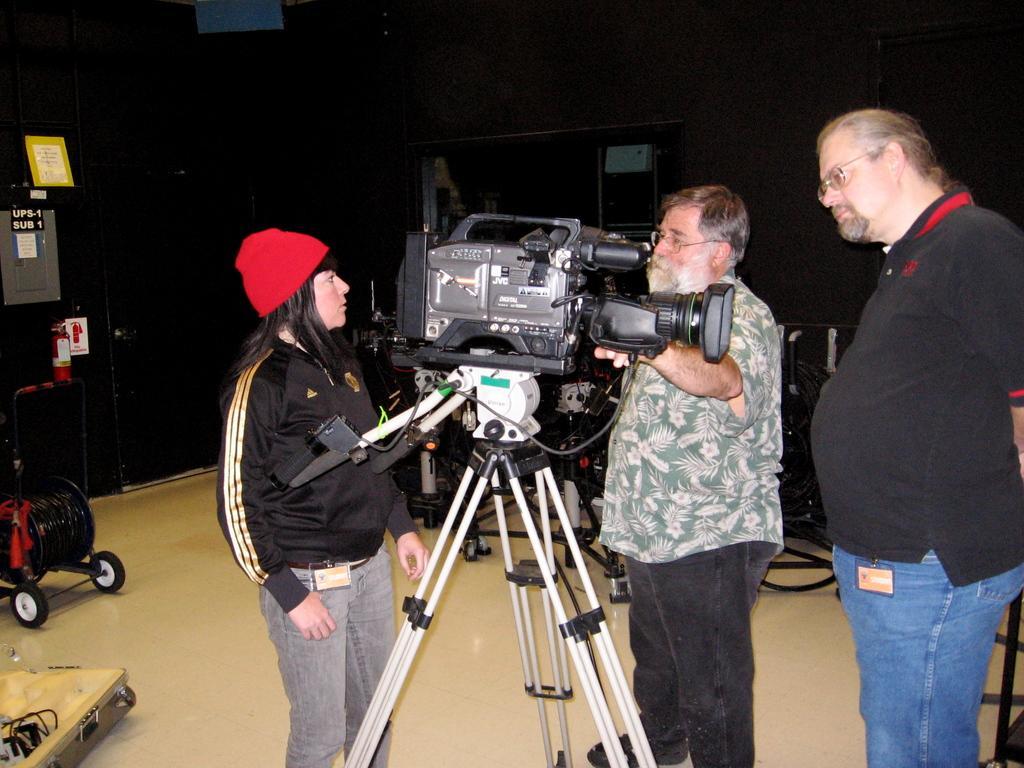Describe this image in one or two sentences. In this image we can see three persons, there is a camera on the tripod, there are trolleys, boards with some text on them, there are wires, also we can see the wall. 